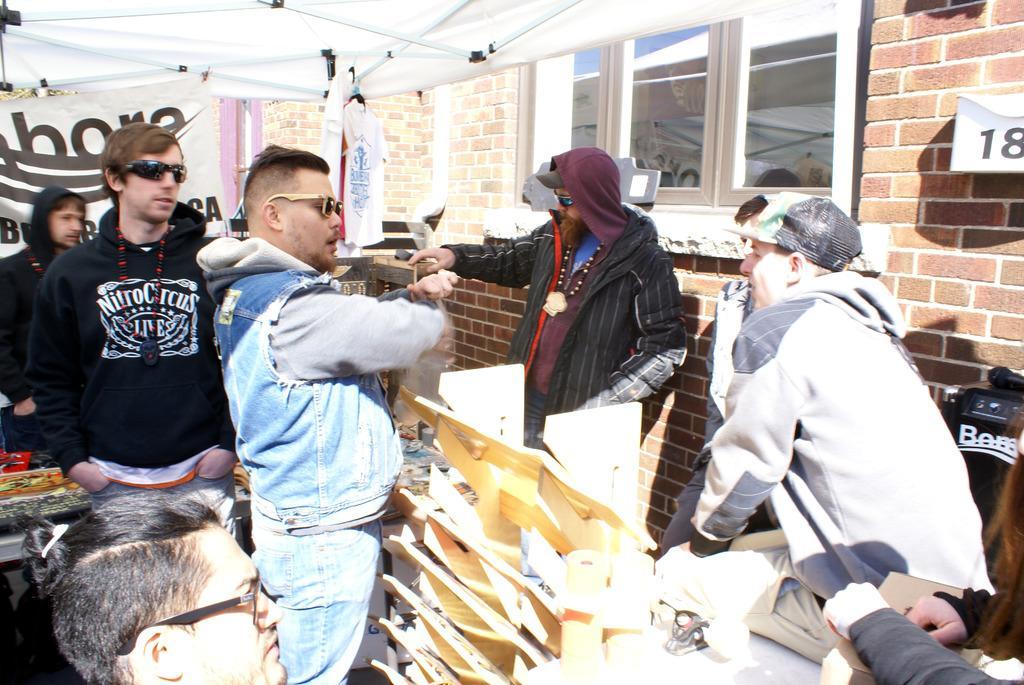How would you summarize this image in a sentence or two? In this picture we can observe some men. Most of them are wearing spectacles. There is a white color tent above them. We can observe windows and a wall. In the background there is a white color T shirt hanging. 